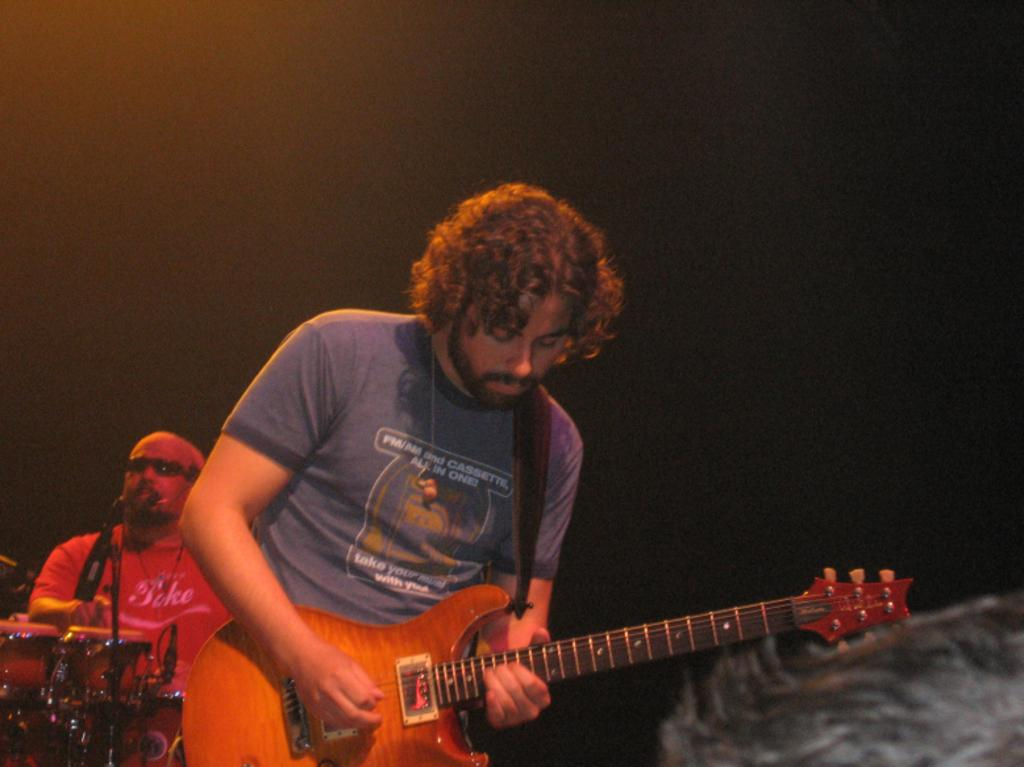How many people are in the image? There are two men in the image. What are the men doing in the image? One of the men is playing a guitar, and the other man is playing drums. Can you describe the background of the image? The background of the image is blurry and dark. What type of cup is being used as a reward for the rat in the image? There is no cup or rat present in the image. 